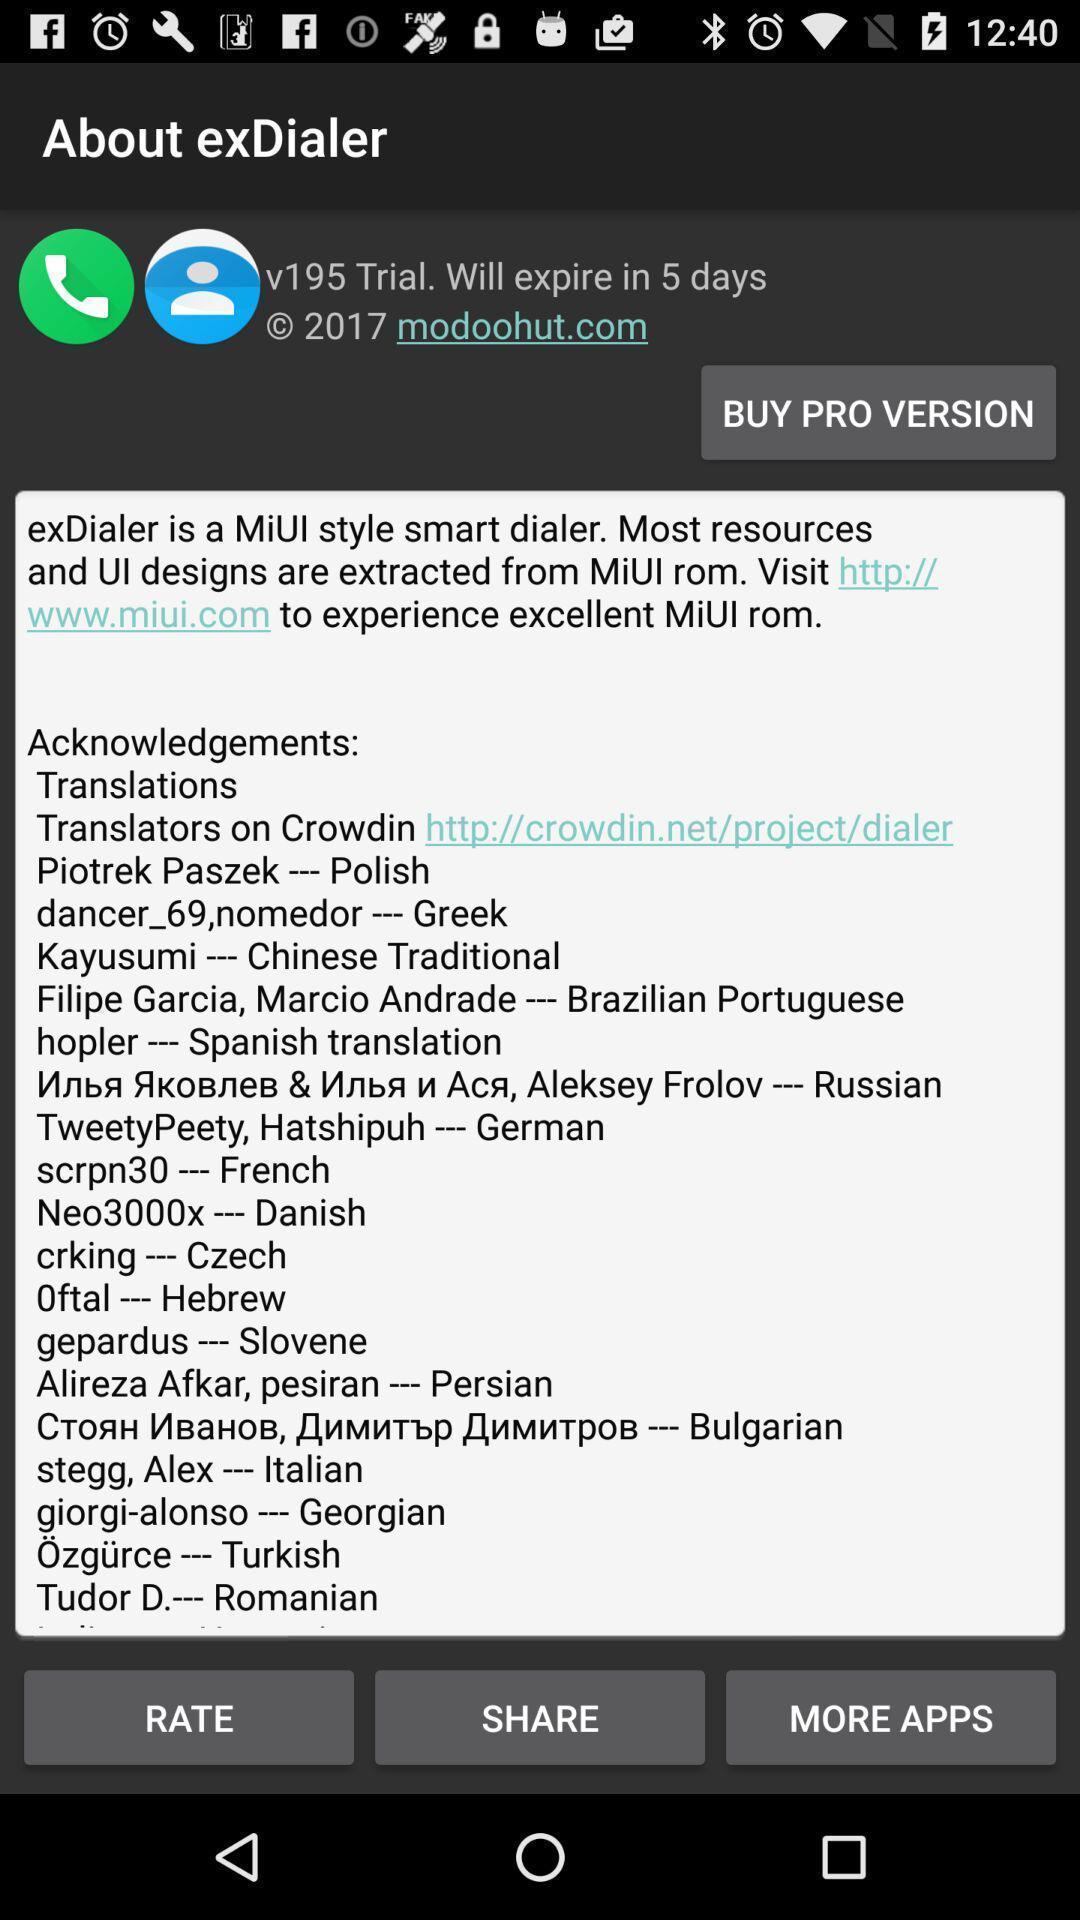Please provide a description for this image. Page displays to rate an app. 